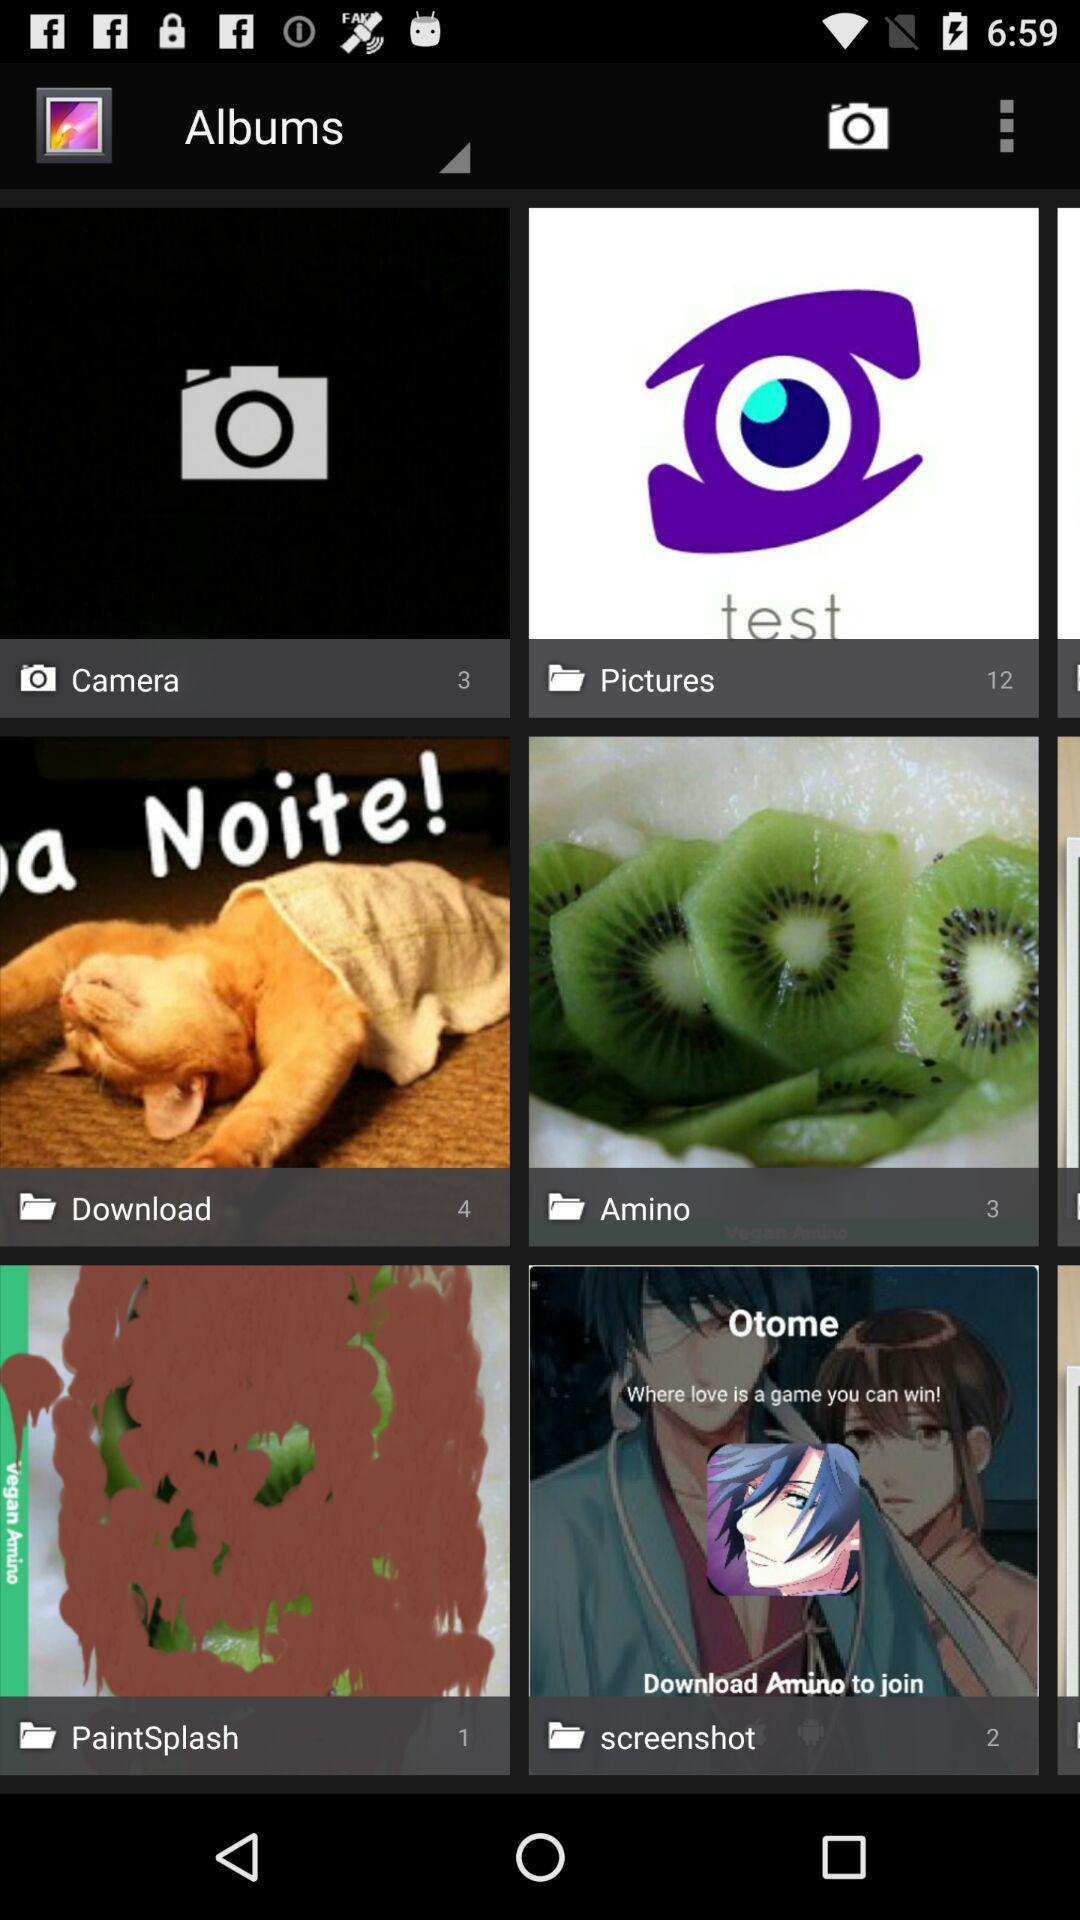How many images are there in the "Pictures" folder? There are 12 images in the "Pictures" folder. 